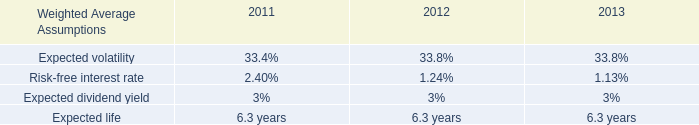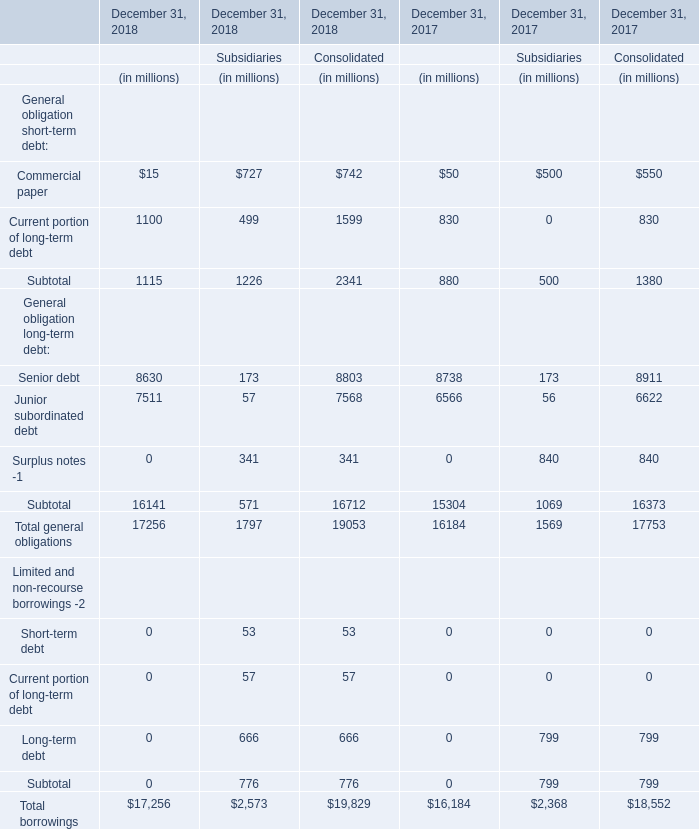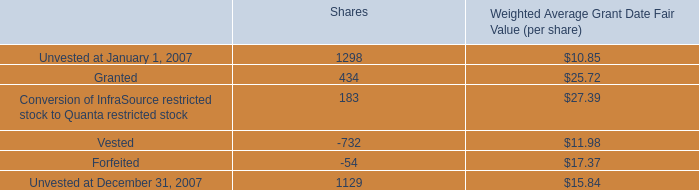What was the total amount of PrudentialFinancial in 2018 ? (in million) 
Computations: (((1115 + 16141) + 17256) + 17256)
Answer: 51768.0. 